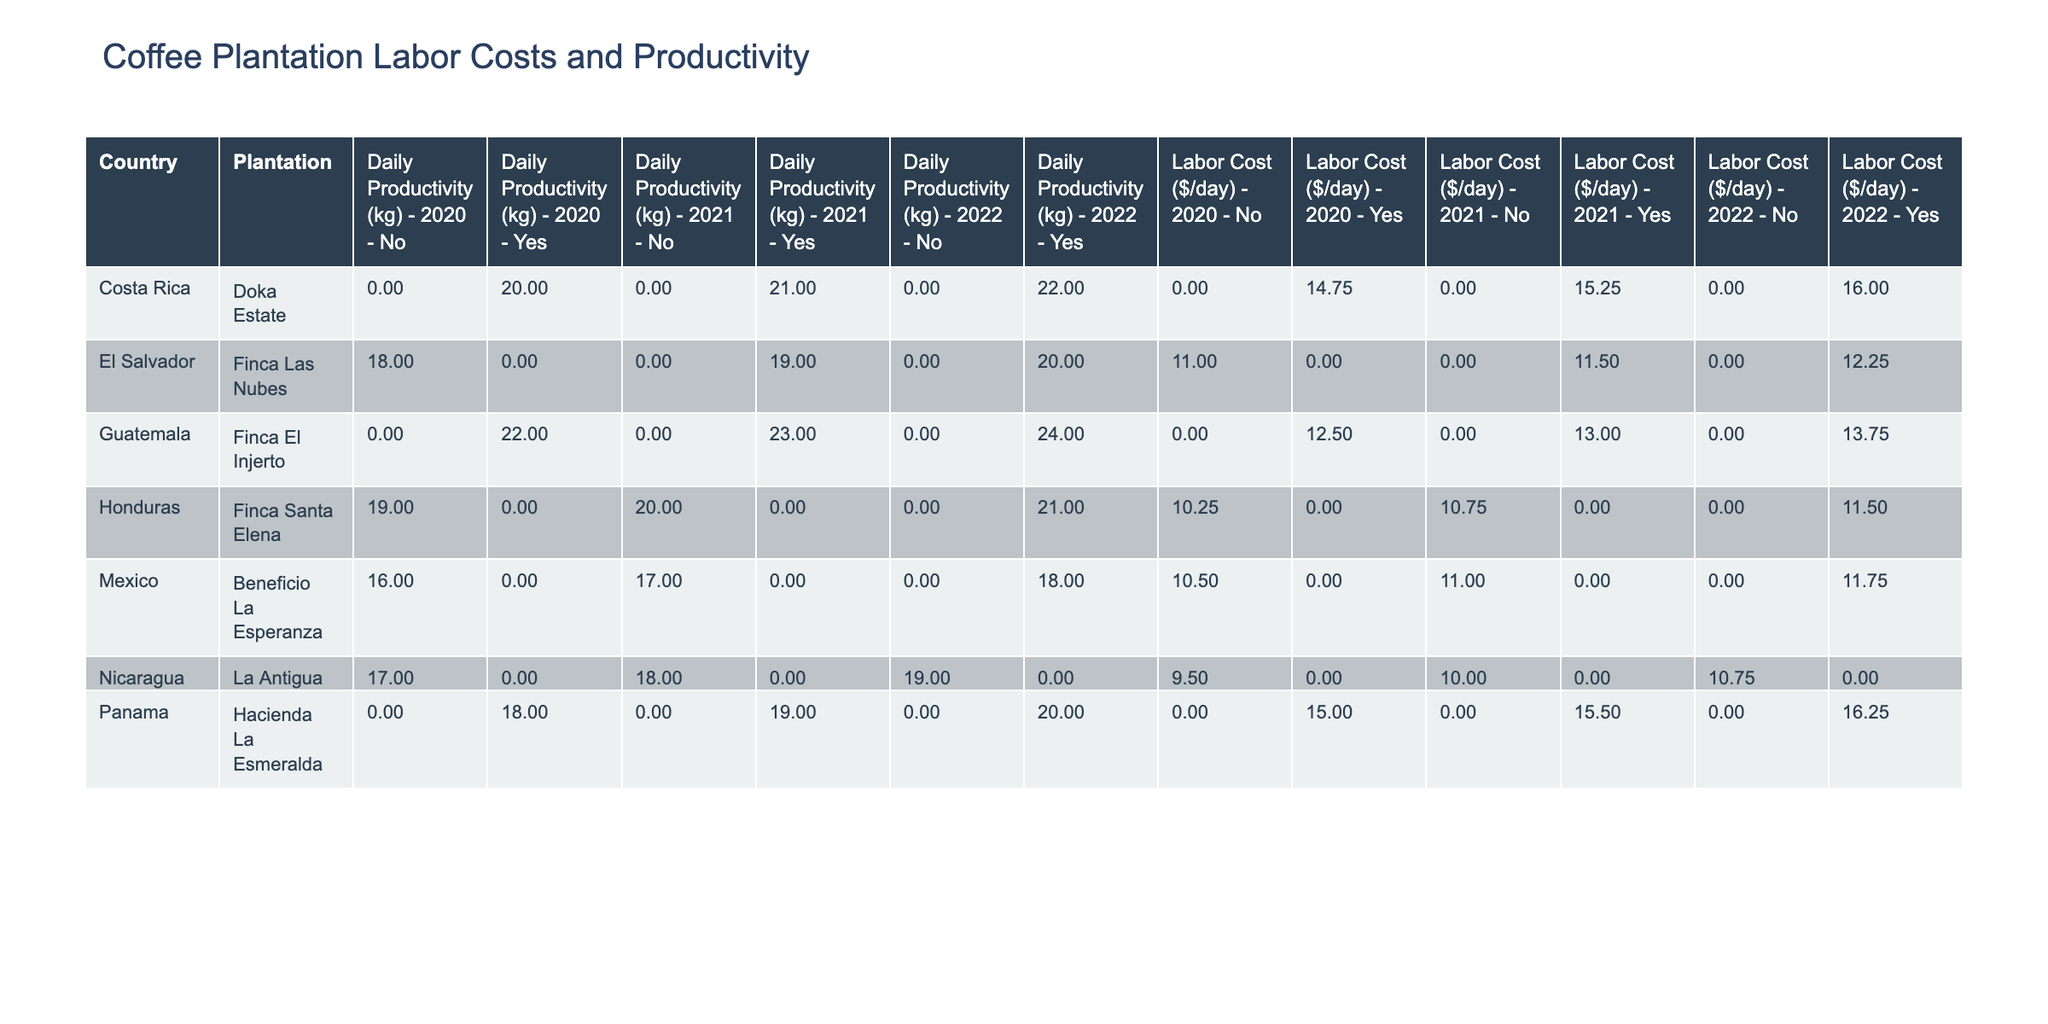What is the daily labor cost for Finca El Injerto in 2022? In the table, I locate Finca El Injerto under Guatemala and find the row corresponding to the year 2022. The labor cost is listed as 13.75.
Answer: 13.75 Which plantation in Panama has the highest labor cost per day in 2021? I look at the rows for Panama in the 2021 column. The labor costs are 15.50 for Hacienda La Esmeralda and there's only one entry for Panama in that year. Therefore, Hacienda La Esmeralda has the highest labor cost.
Answer: Hacienda La Esmeralda What is the average daily productivity for all plantations in Costa Rica in 2020? In the 2020 section, there is only one plantation from Costa Rica, which is Doka Estate with a productivity of 20 kg. Since it's the only entry, the average is simply 20 kg.
Answer: 20 kg Is Finca Santa Elena Fair Trade Certified in 2022? I check the entry for Finca Santa Elena in the 2022 column. The row states 'Yes' under the Fair Trade Certified column.
Answer: Yes How does the daily productivity of Doka Estate change from 2020 to 2022? In 2020, Doka Estate's daily productivity is 20 kg, and in 2022 it rises to 22 kg. The change implies an increase of 2 kg.
Answer: Increase of 2 kg What is the total number of workers across Fair Trade Certified plantations in 2021? I identify the Fair Trade Certified plantations in 2021: Finca El Injerto (155 workers), Hacienda La Esmeralda (85 workers), and Doka Estate (125 workers). I sum these numbers: 155 + 85 + 125 = 365 workers.
Answer: 365 workers Which country has the lowest average daily productivity across all years? I compute the average daily productivity for each country: Guatemala (average 23 kg), Panama (average 19 kg), Costa Rica (average 21 kg), Honduras (average 20 kg), Nicaragua (average 18 kg), and El Salvador (average 19 kg). The lowest average is for Nicaragua at 18 kg.
Answer: Nicaragua Was there any year when Beneficio La Esperanza had a higher daily productivity than Finca Las Nubes? I check each year for both plantations. For 2020, Beneficio La Esperanza was 16 kg and Finca Las Nubes was 18 kg. In 2021, Beneficio La Esperanza was at 17 kg and Finca Las Nubes was at 19 kg. In 2022, Beneficio La Esperanza was 18 kg and Finca Las Nubes was 20 kg. In all years, Beneficio La Esperanza has lower productivity than Finca Las Nubes.
Answer: No What is the difference in labor cost per day between the highest and lowest reported values for 2022? I check 2022 for the highest labor cost, which is 16.25 (Hacienda La Esmeralda), and the lowest is 10.75 (La Antigua). The difference is 16.25 - 10.75 = 5.50.
Answer: 5.50 